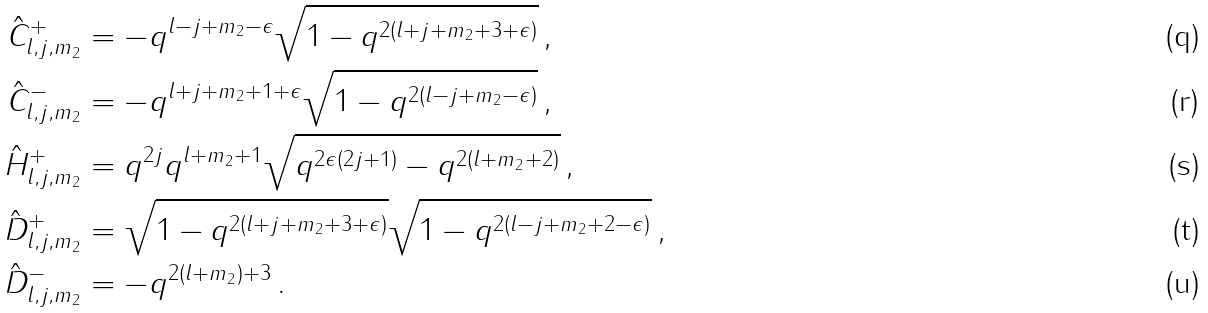Convert formula to latex. <formula><loc_0><loc_0><loc_500><loc_500>\hat { C } ^ { + } _ { l , j , m _ { 2 } } & = - q ^ { l - j + m _ { 2 } - \epsilon } \sqrt { 1 - q ^ { 2 ( l + j + m _ { 2 } + 3 + \epsilon ) } } \, , \\ \hat { C } ^ { - } _ { l , j , m _ { 2 } } & = - q ^ { l + j + m _ { 2 } + 1 + \epsilon } \sqrt { 1 - q ^ { 2 ( l - j + m _ { 2 } - \epsilon ) } } \, , \\ \hat { H } ^ { + } _ { l , j , m _ { 2 } } & = q ^ { 2 j } q ^ { l + m _ { 2 } + 1 } \sqrt { q ^ { 2 \epsilon ( 2 j + 1 ) } - q ^ { 2 ( l + m _ { 2 } + 2 ) } } \, , \\ \hat { D } _ { l , j , m _ { 2 } } ^ { + } & = \sqrt { 1 - q ^ { 2 ( l + j + m _ { 2 } + 3 + \epsilon ) } } \sqrt { 1 - q ^ { 2 ( l - j + m _ { 2 } + 2 - \epsilon ) } } \, , \\ \hat { D } _ { l , j , m _ { 2 } } ^ { - } & = - q ^ { 2 ( l + m _ { 2 } ) + 3 } \, .</formula> 